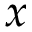Convert formula to latex. <formula><loc_0><loc_0><loc_500><loc_500>x</formula> 